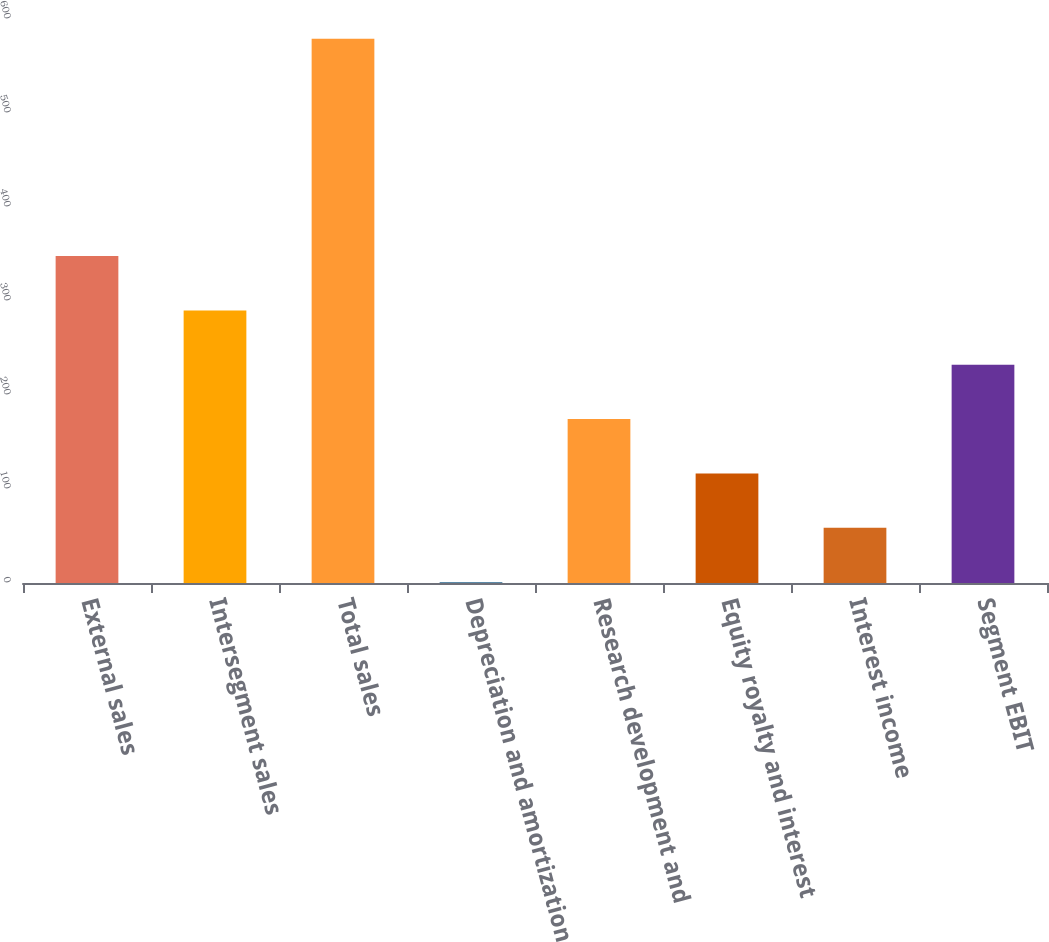<chart> <loc_0><loc_0><loc_500><loc_500><bar_chart><fcel>External sales<fcel>Intersegment sales<fcel>Total sales<fcel>Depreciation and amortization<fcel>Research development and<fcel>Equity royalty and interest<fcel>Interest income<fcel>Segment EBIT<nl><fcel>347.8<fcel>290<fcel>579<fcel>1<fcel>174.4<fcel>116.6<fcel>58.8<fcel>232.2<nl></chart> 